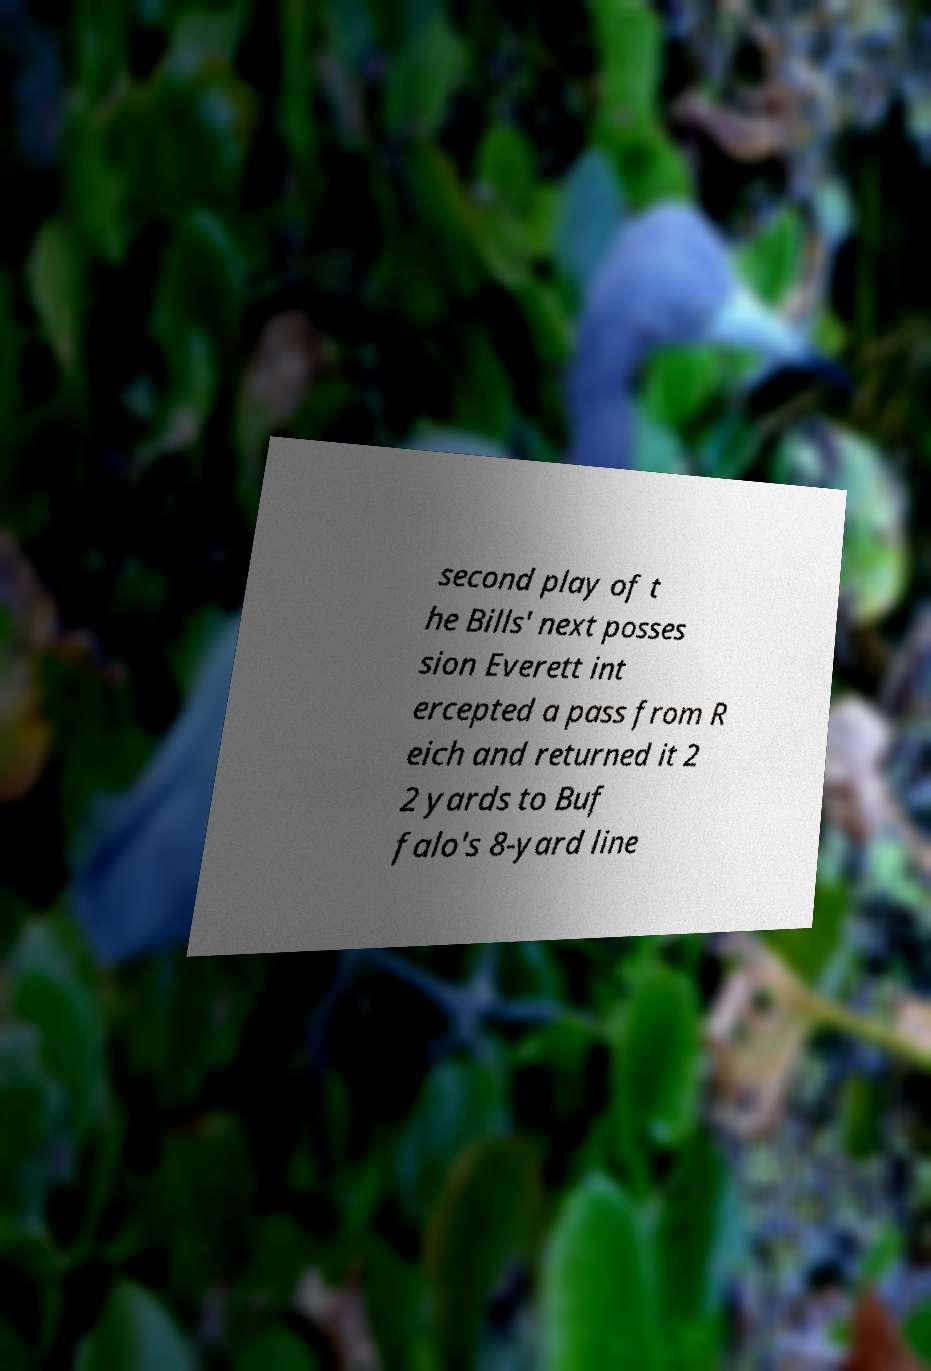What messages or text are displayed in this image? I need them in a readable, typed format. second play of t he Bills' next posses sion Everett int ercepted a pass from R eich and returned it 2 2 yards to Buf falo's 8-yard line 